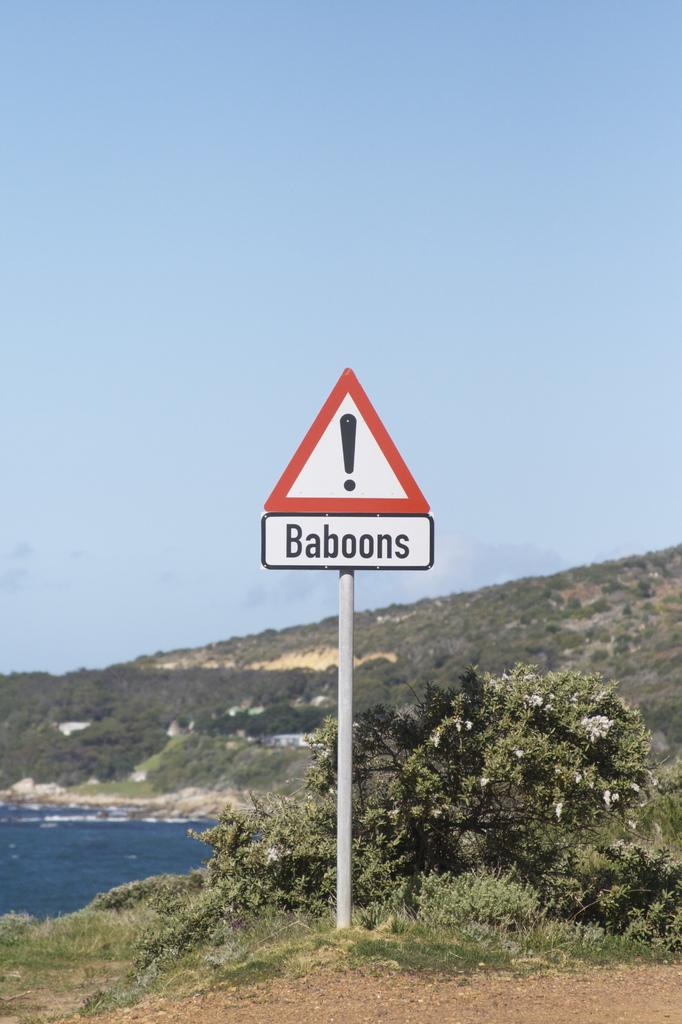<image>
Give a short and clear explanation of the subsequent image. A triangular sign that has a exclamation point and says baboons in a smaller sign beneath it. 